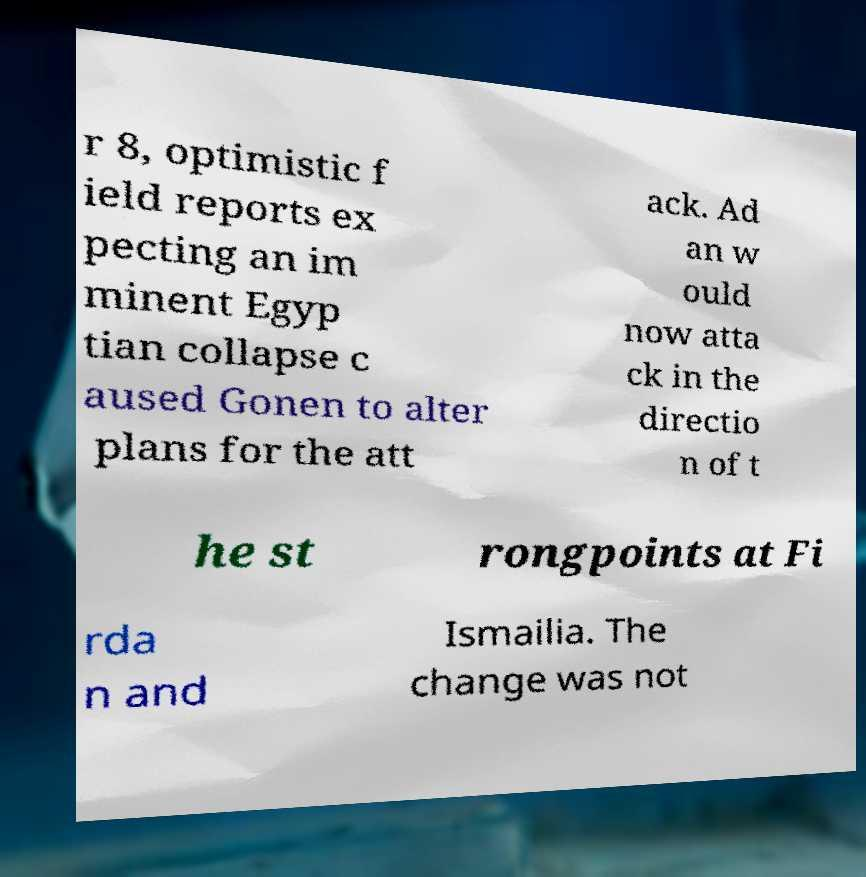There's text embedded in this image that I need extracted. Can you transcribe it verbatim? r 8, optimistic f ield reports ex pecting an im minent Egyp tian collapse c aused Gonen to alter plans for the att ack. Ad an w ould now atta ck in the directio n of t he st rongpoints at Fi rda n and Ismailia. The change was not 